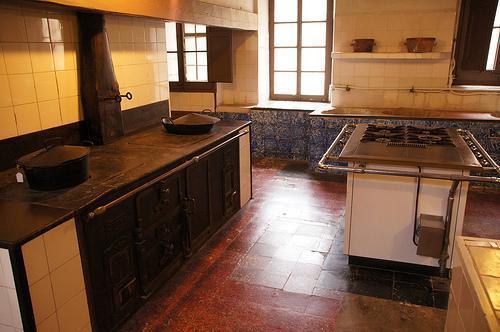How many stoves are there?
Give a very brief answer. 1. 